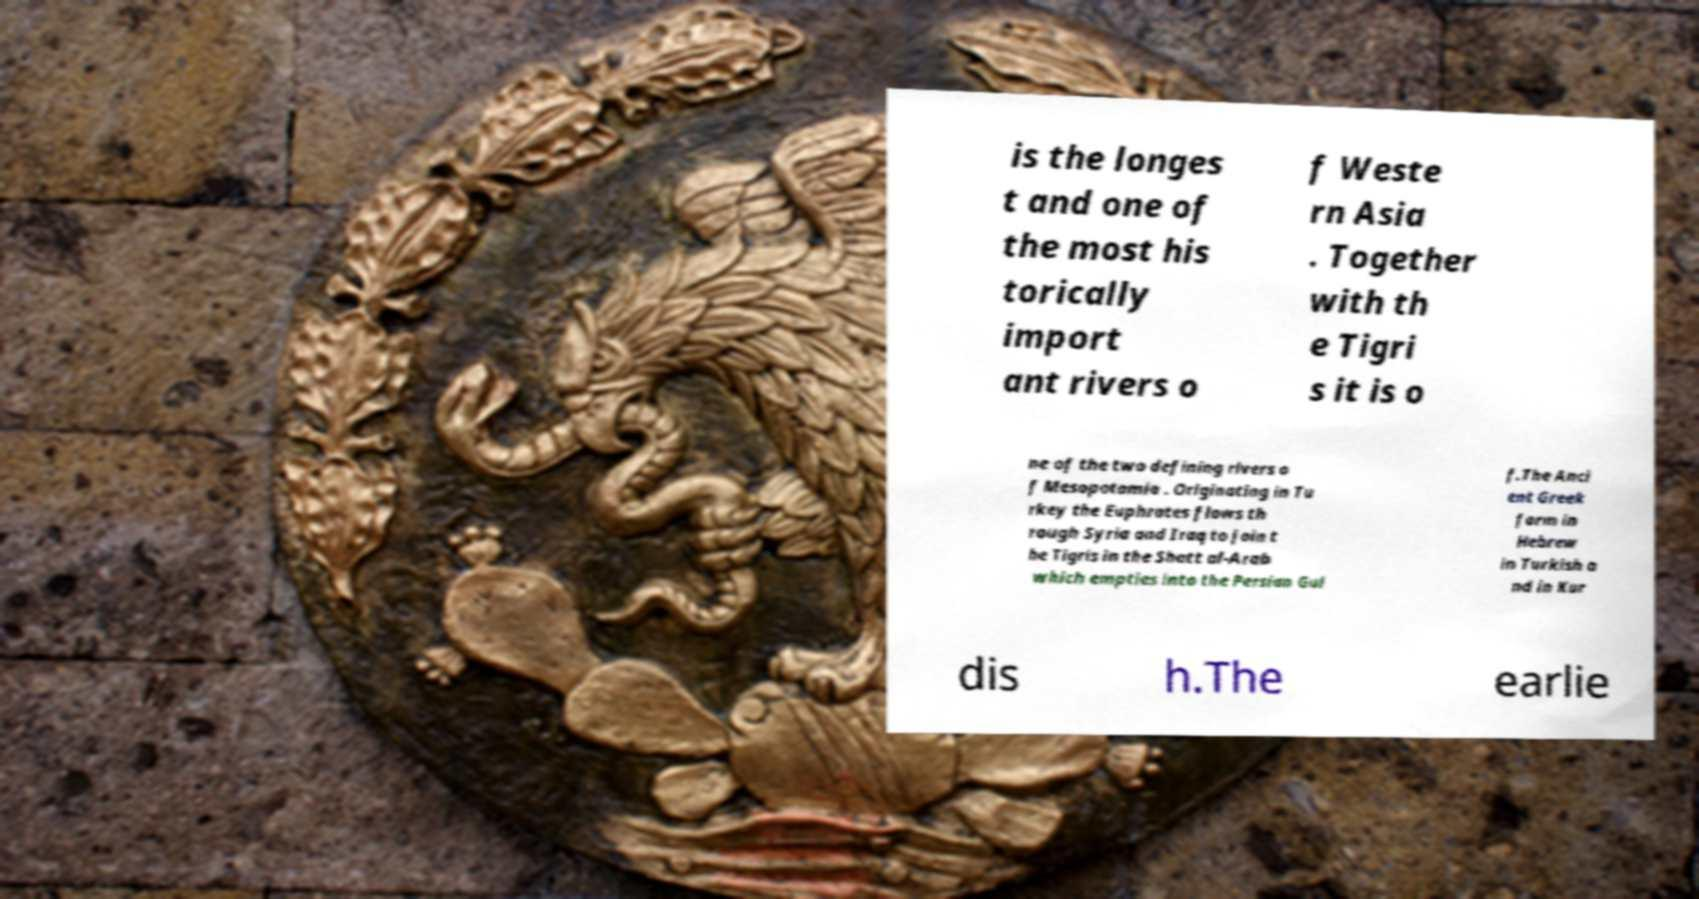Could you assist in decoding the text presented in this image and type it out clearly? is the longes t and one of the most his torically import ant rivers o f Weste rn Asia . Together with th e Tigri s it is o ne of the two defining rivers o f Mesopotamia . Originating in Tu rkey the Euphrates flows th rough Syria and Iraq to join t he Tigris in the Shatt al-Arab which empties into the Persian Gul f.The Anci ent Greek form in Hebrew in Turkish a nd in Kur dis h.The earlie 